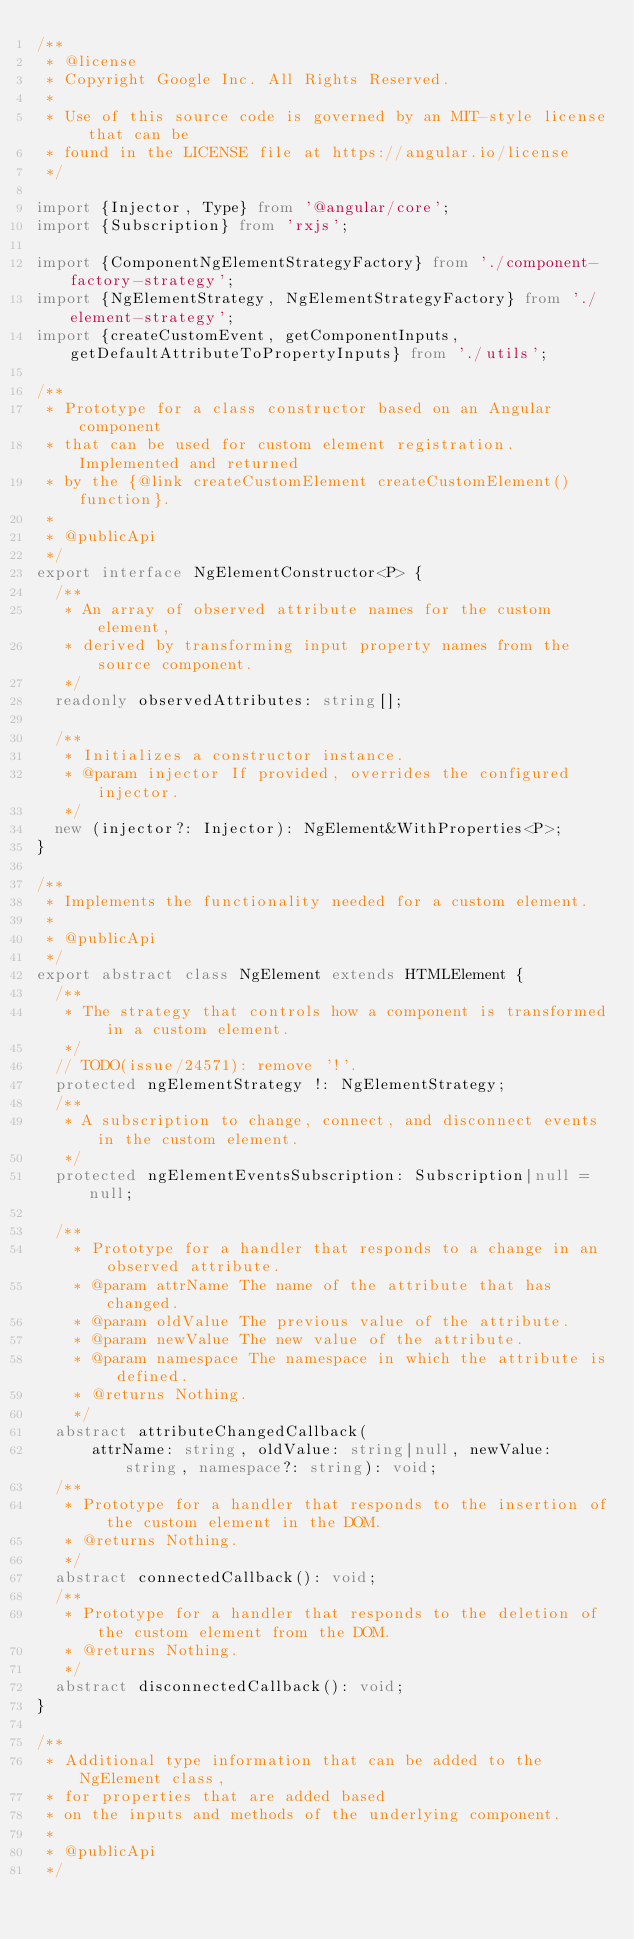Convert code to text. <code><loc_0><loc_0><loc_500><loc_500><_TypeScript_>/**
 * @license
 * Copyright Google Inc. All Rights Reserved.
 *
 * Use of this source code is governed by an MIT-style license that can be
 * found in the LICENSE file at https://angular.io/license
 */

import {Injector, Type} from '@angular/core';
import {Subscription} from 'rxjs';

import {ComponentNgElementStrategyFactory} from './component-factory-strategy';
import {NgElementStrategy, NgElementStrategyFactory} from './element-strategy';
import {createCustomEvent, getComponentInputs, getDefaultAttributeToPropertyInputs} from './utils';

/**
 * Prototype for a class constructor based on an Angular component
 * that can be used for custom element registration. Implemented and returned
 * by the {@link createCustomElement createCustomElement() function}.
 *
 * @publicApi
 */
export interface NgElementConstructor<P> {
  /**
   * An array of observed attribute names for the custom element,
   * derived by transforming input property names from the source component.
   */
  readonly observedAttributes: string[];

  /**
   * Initializes a constructor instance.
   * @param injector If provided, overrides the configured injector.
   */
  new (injector?: Injector): NgElement&WithProperties<P>;
}

/**
 * Implements the functionality needed for a custom element.
 *
 * @publicApi
 */
export abstract class NgElement extends HTMLElement {
  /**
   * The strategy that controls how a component is transformed in a custom element.
   */
  // TODO(issue/24571): remove '!'.
  protected ngElementStrategy !: NgElementStrategy;
  /**
   * A subscription to change, connect, and disconnect events in the custom element.
   */
  protected ngElementEventsSubscription: Subscription|null = null;

  /**
    * Prototype for a handler that responds to a change in an observed attribute.
    * @param attrName The name of the attribute that has changed.
    * @param oldValue The previous value of the attribute.
    * @param newValue The new value of the attribute.
    * @param namespace The namespace in which the attribute is defined.
    * @returns Nothing.
    */
  abstract attributeChangedCallback(
      attrName: string, oldValue: string|null, newValue: string, namespace?: string): void;
  /**
   * Prototype for a handler that responds to the insertion of the custom element in the DOM.
   * @returns Nothing.
   */
  abstract connectedCallback(): void;
  /**
   * Prototype for a handler that responds to the deletion of the custom element from the DOM.
   * @returns Nothing.
   */
  abstract disconnectedCallback(): void;
}

/**
 * Additional type information that can be added to the NgElement class,
 * for properties that are added based
 * on the inputs and methods of the underlying component.
 *
 * @publicApi
 */</code> 